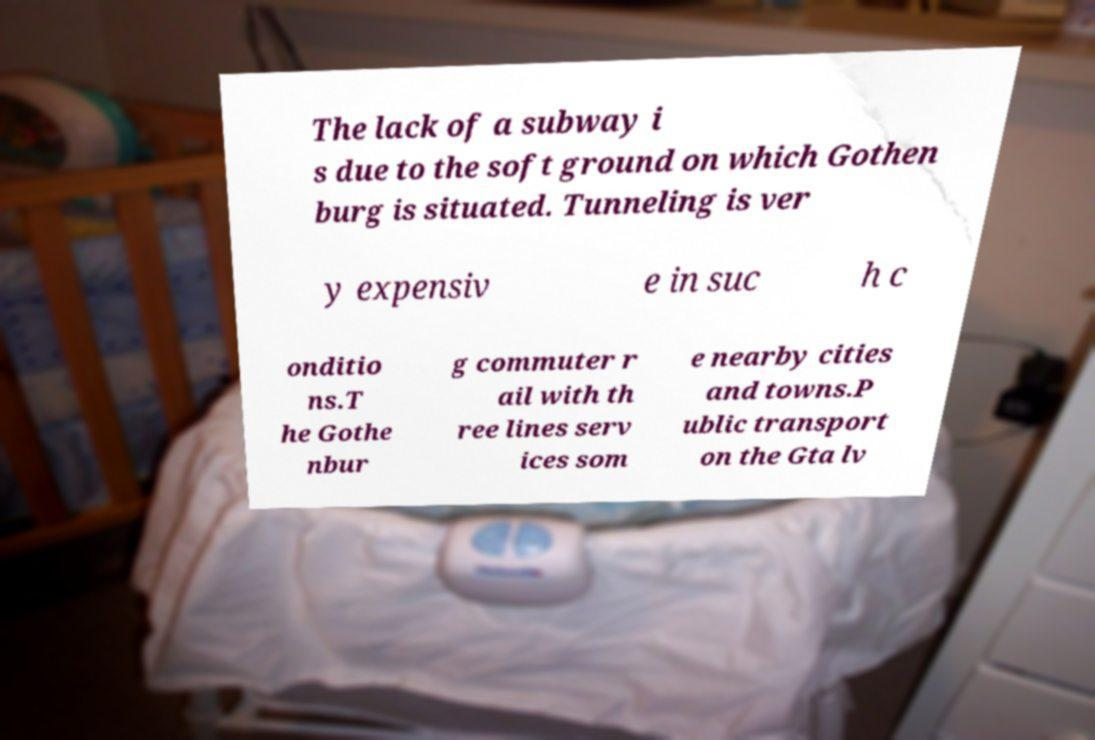I need the written content from this picture converted into text. Can you do that? The lack of a subway i s due to the soft ground on which Gothen burg is situated. Tunneling is ver y expensiv e in suc h c onditio ns.T he Gothe nbur g commuter r ail with th ree lines serv ices som e nearby cities and towns.P ublic transport on the Gta lv 